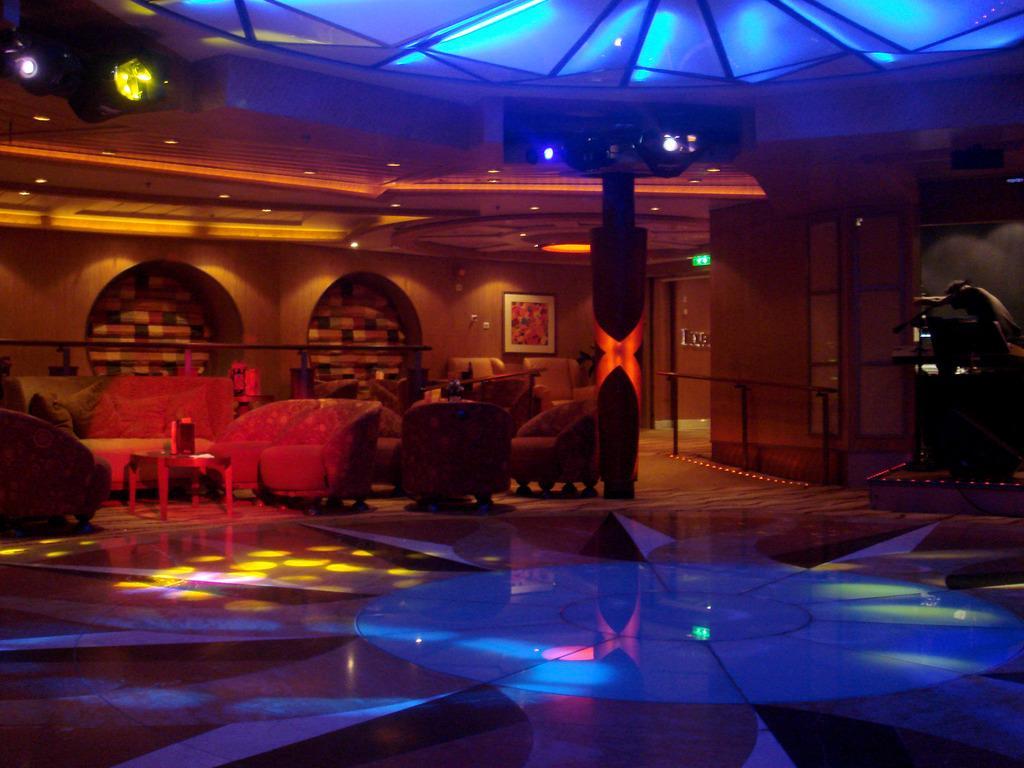Please provide a concise description of this image. In this image we can see some chairs, sofas and a table on the floor. We can also see a pole, some lights, a frame on a wall, a signboard and a roof with some ceiling lights. On the right side we can see a person. 